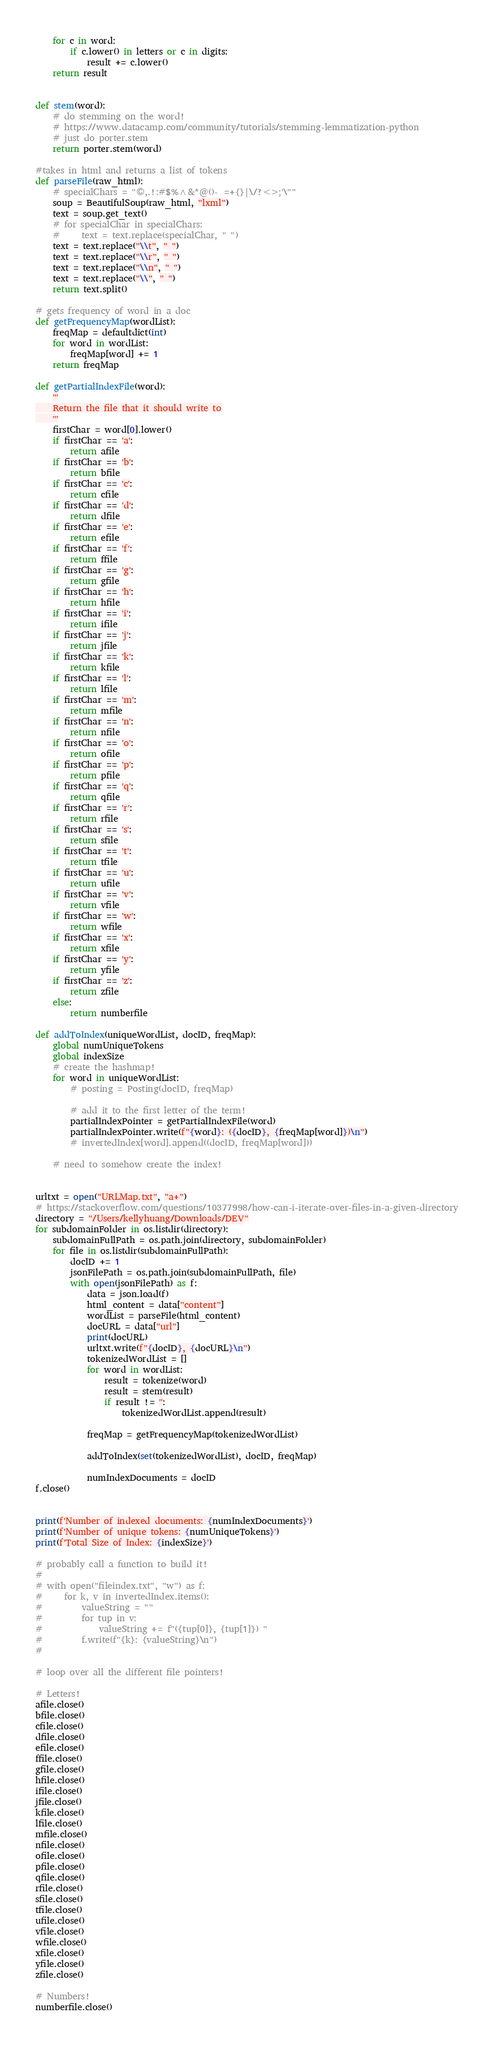Convert code to text. <code><loc_0><loc_0><loc_500><loc_500><_Python_>
    for c in word:
        if c.lower() in letters or c in digits:
            result += c.lower()
    return result


def stem(word):
    # do stemming on the word!
    # https://www.datacamp.com/community/tutorials/stemming-lemmatization-python
    # just do porter.stem
    return porter.stem(word)

#takes in html and returns a list of tokens
def parseFile(raw_html):
    # specialChars = "©,.!:#$%^&*@()-_=+{}|\/?<>;'\""
    soup = BeautifulSoup(raw_html, "lxml")
    text = soup.get_text()
    # for specialChar in specialChars:
    #     text = text.replace(specialChar, " ")
    text = text.replace("\\t", " ")
    text = text.replace("\\r", " ")
    text = text.replace("\\n", " ")
    text = text.replace("\\", " ")
    return text.split()

# gets frequency of word in a doc
def getFrequencyMap(wordList):
    freqMap = defaultdict(int)
    for word in wordList:
        freqMap[word] += 1
    return freqMap

def getPartialIndexFile(word):
    '''
    Return the file that it should write to
    '''
    firstChar = word[0].lower()
    if firstChar == 'a':
        return afile
    if firstChar == 'b':
        return bfile
    if firstChar == 'c':
        return cfile
    if firstChar == 'd':
        return dfile
    if firstChar == 'e':
        return efile
    if firstChar == 'f':
        return ffile
    if firstChar == 'g':
        return gfile
    if firstChar == 'h':
        return hfile
    if firstChar == 'i':
        return ifile
    if firstChar == 'j':
        return jfile
    if firstChar == 'k':
        return kfile
    if firstChar == 'l':
        return lfile
    if firstChar == 'm':
        return mfile
    if firstChar == 'n':
        return nfile
    if firstChar == 'o':
        return ofile
    if firstChar == 'p':
        return pfile
    if firstChar == 'q':
        return qfile
    if firstChar == 'r':
        return rfile
    if firstChar == 's':
        return sfile
    if firstChar == 't':
        return tfile
    if firstChar == 'u':
        return ufile
    if firstChar == 'v':
        return vfile
    if firstChar == 'w':
        return wfile
    if firstChar == 'x':
        return xfile
    if firstChar == 'y':
        return yfile
    if firstChar == 'z':
        return zfile
    else:
        return numberfile

def addToIndex(uniqueWordList, docID, freqMap):
    global numUniqueTokens
    global indexSize
    # create the hashmap!
    for word in uniqueWordList:
        # posting = Posting(docID, freqMap)

        # add it to the first letter of the term!
        partialIndexPointer = getPartialIndexFile(word)
        partialIndexPointer.write(f"{word}: ({docID}, {freqMap[word]})\n")
        # invertedIndex[word].append((docID, freqMap[word]))

    # need to somehow create the index!


urltxt = open("URLMap.txt", "a+")
# https://stackoverflow.com/questions/10377998/how-can-i-iterate-over-files-in-a-given-directory
directory = "/Users/kellyhuang/Downloads/DEV"
for subdomainFolder in os.listdir(directory):
    subdomainFullPath = os.path.join(directory, subdomainFolder)
    for file in os.listdir(subdomainFullPath):
        docID += 1
        jsonFilePath = os.path.join(subdomainFullPath, file)
        with open(jsonFilePath) as f:
            data = json.load(f)
            html_content = data["content"]
            wordList = parseFile(html_content)
            docURL = data["url"]
            print(docURL)
            urltxt.write(f"{docID}, {docURL}\n")
            tokenizedWordList = []
            for word in wordList:
                result = tokenize(word)
                result = stem(result)
                if result != '':
                    tokenizedWordList.append(result)

            freqMap = getFrequencyMap(tokenizedWordList)

            addToIndex(set(tokenizedWordList), docID, freqMap)

            numIndexDocuments = docID
f.close()


print(f'Number of indexed documents: {numIndexDocuments}')
print(f'Number of unique tokens: {numUniqueTokens}')
print(f'Total Size of Index: {indexSize}')

# probably call a function to build it!
#
# with open("fileindex.txt", "w") as f:
#     for k, v in invertedIndex.items():
#         valueString = ""
#         for tup in v:
#             valueString += f"({tup[0]}, {tup[1]}) "
#         f.write(f"{k}: {valueString}\n")
#

# loop over all the different file pointers!

# Letters!
afile.close()
bfile.close()
cfile.close()
dfile.close()
efile.close()
ffile.close()
gfile.close()
hfile.close()
ifile.close()
jfile.close()
kfile.close()
lfile.close()
mfile.close()
nfile.close()
ofile.close()
pfile.close()
qfile.close()
rfile.close()
sfile.close()
tfile.close()
ufile.close()
vfile.close()
wfile.close()
xfile.close()
yfile.close()
zfile.close()

# Numbers!
numberfile.close()</code> 